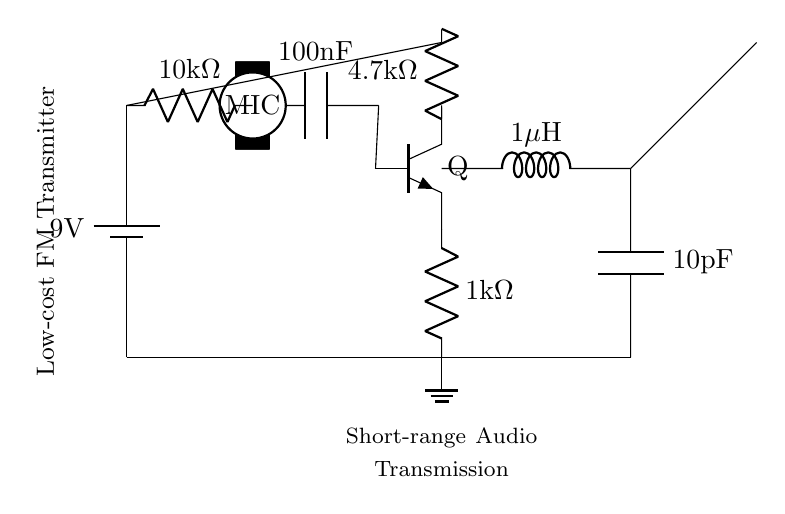What is the supply voltage of the circuit? The circuit is powered by a battery, which is labeled as 9V. This indicates the voltage supplied to the components in the circuit.
Answer: 9V What type of transistor is used in this circuit? The diagram specifies an NP transistor (indicated by the symbol with an N-doped emitter and a P-doped base) labeled as Q.
Answer: NP What is the value of the capacitor connected to the microphone? The capacitor connected to the microphone is labeled as 100nF, which is a typical value for coupling audio signals in such circuits.
Answer: 100nF How many resistors are present in the circuit diagram? The circuit includes three resistors: one is 10k ohms, another is 1k ohm, and the third is 4.7k ohms. Counting these gives a total of three resistors.
Answer: 3 What is the purpose of the inductor in the tank circuit? The inductor, valued at 1uH, along with the capacitor, forms a tank circuit that is crucial for generating the FM signal, enabling tuning to specific frequencies for transmission.
Answer: Generating signal What would happen if the microphone were removed from the circuit? Removing the microphone would sever the audio input path, meaning no audio signal would be amplified or transmitted, effectively rendering the circuit non-functional for its intended purpose.
Answer: No audio signal What is the purpose of the antenna in this circuit? The antenna is used to radiate the modulated FM signal generated by the circuit into the air, allowing the audio transmission to occur over short ranges.
Answer: Radiate signal 